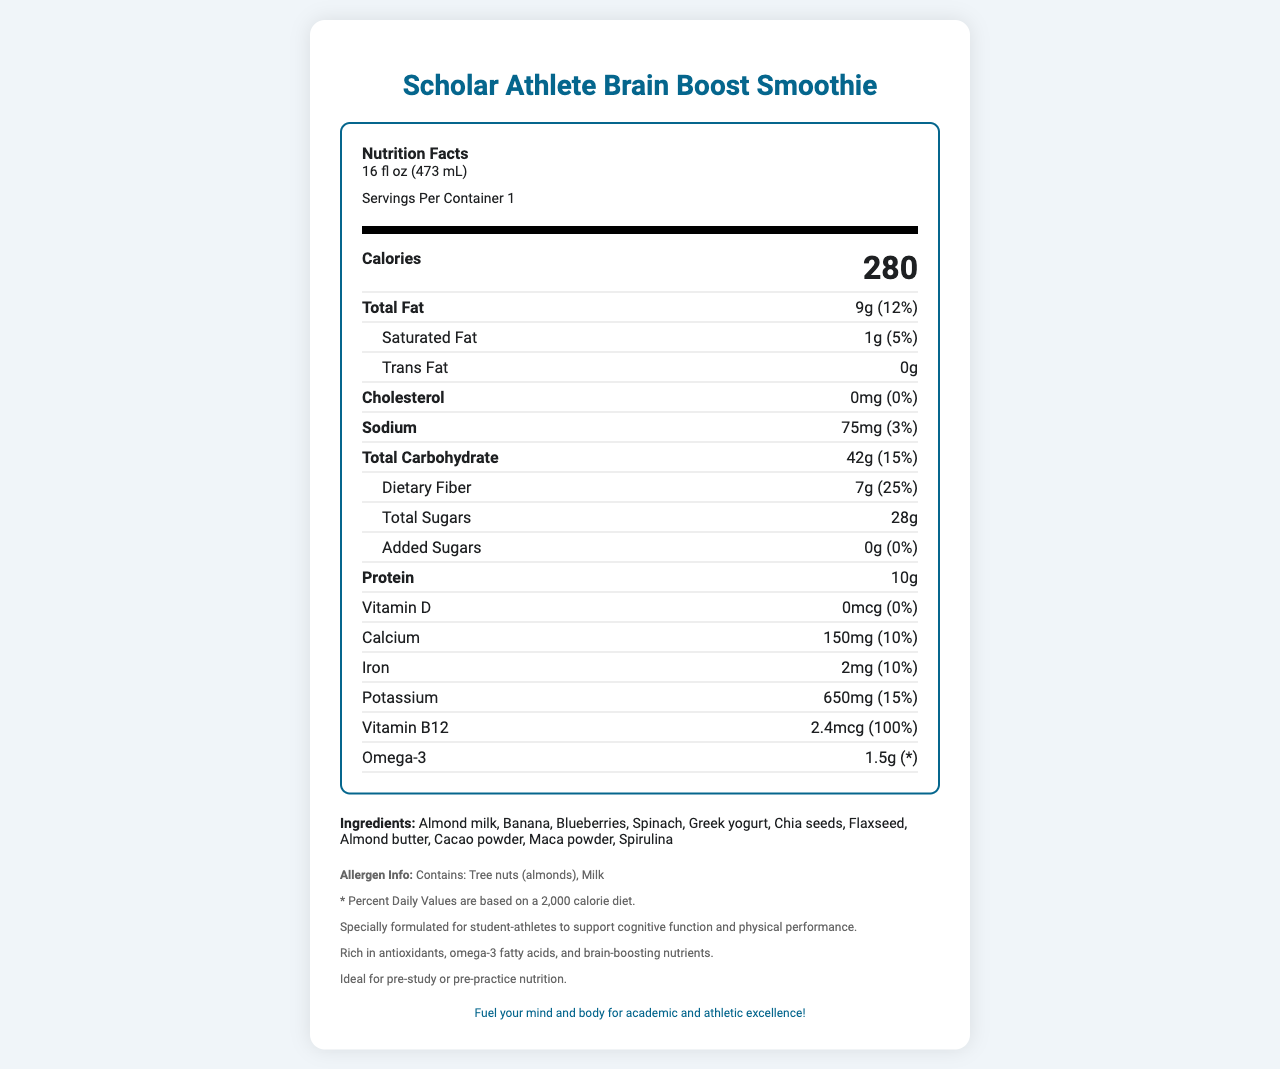what is the serving size mentioned on the label? The serving size is clearly listed at the top of the nutrition label under the product name.
Answer: 16 fl oz (473 mL) how many calories are in one serving of the Scholar Athlete Brain Boost Smoothie? The amount of calories is prominently displayed in the middle of the nutrition facts section.
Answer: 280 how much dietary fiber does the smoothie contain? The dietary fiber content is listed under the total carbohydrates section in the nutrition label.
Answer: 7g what percentage of the daily value for vitamin B12 is provided by this smoothie? The daily value percentage for vitamin B12 is given at the bottom part of the nutrition facts section.
Answer: 100% how much protein is in the Scholar Athlete Brain Boost Smoothie? The protein content is listed in the nutrition information section under the calorie count.
Answer: 10g which of the following ingredients is NOT in the smoothie? A. Chia seeds B. Kale C. Blueberries D. Greek yogurt The list of ingredients includes chia seeds, blueberries, and Greek yogurt, but kale is not mentioned.
Answer: B. Kale what is the main source of allergens in this product? The allergen information at the bottom of the document lists tree nuts (almonds) and milk as sources.
Answer: Tree nuts (almonds), Milk how much potassium does one serving of this smoothie provide? The potassium amount is located in the nutrition facts and is measured as 650mg.
Answer: 650mg does the smoothie contain any added sugars? The added sugars section indicates that there are 0g of added sugars, which translates to 0% of the daily value.
Answer: No what is the total fat content in a single serving? The total fat content per serving is listed at the top portion of the nutrition facts section.
Answer: 9g the smoothie has been specially formulated for which group of individuals? A. Children B. Athletes C. Elderly people D. Pregnant women The additional information section notes that the smoothie is specially formulated for student-athletes.
Answer: B. Athletes what is the document's main idea? The document focuses on presenting the nutritional facts, ingredient list, allergen information, and the benefits of the smoothie in enhancing cognitive function and physical performance, particularly for student-athletes.
Answer: The Scholar Athlete Brain Boost Smoothie is designed to support cognitive function and physical performance for student-athletes, providing essential nutrients, vitamins, and minerals with detailed nutritional information. what is the recommended daily value based on? The document does not provide specific information on the recommended daily values or how they are calculated.
Answer: Cannot be determined is this smoothie an ideal choice for pre-study or pre-practice nutrition according to the document? The additional information section specifies that the smoothie is ideal for pre-study or pre-practice nutrition.
Answer: Yes 